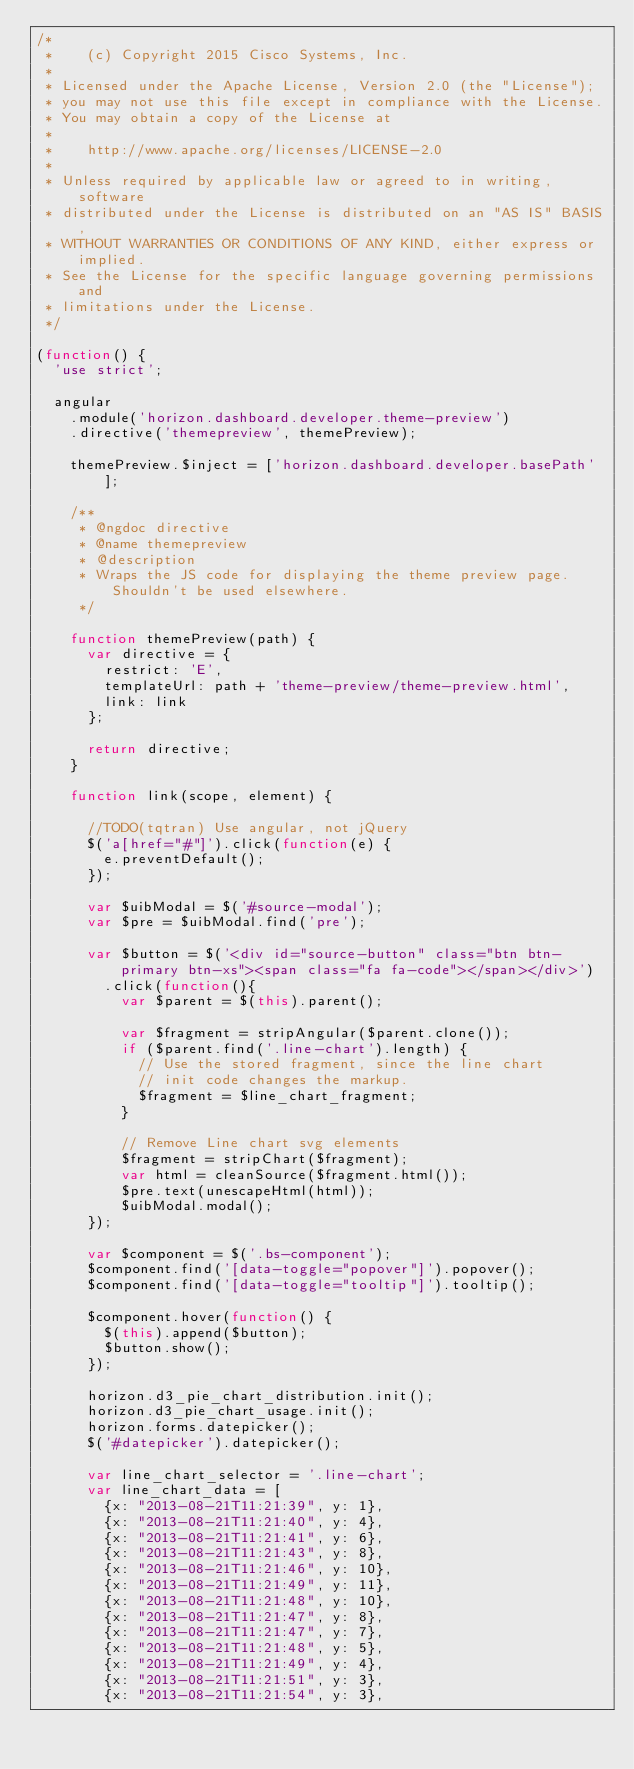<code> <loc_0><loc_0><loc_500><loc_500><_JavaScript_>/*
 *    (c) Copyright 2015 Cisco Systems, Inc.
 *
 * Licensed under the Apache License, Version 2.0 (the "License");
 * you may not use this file except in compliance with the License.
 * You may obtain a copy of the License at
 *
 *    http://www.apache.org/licenses/LICENSE-2.0
 *
 * Unless required by applicable law or agreed to in writing, software
 * distributed under the License is distributed on an "AS IS" BASIS,
 * WITHOUT WARRANTIES OR CONDITIONS OF ANY KIND, either express or implied.
 * See the License for the specific language governing permissions and
 * limitations under the License.
 */

(function() {
  'use strict';

  angular
    .module('horizon.dashboard.developer.theme-preview')
    .directive('themepreview', themePreview);

    themePreview.$inject = ['horizon.dashboard.developer.basePath'];

    /**
     * @ngdoc directive
     * @name themepreview
     * @description
     * Wraps the JS code for displaying the theme preview page. Shouldn't be used elsewhere.
     */

    function themePreview(path) {
      var directive = {
        restrict: 'E',
        templateUrl: path + 'theme-preview/theme-preview.html',
        link: link
      };

      return directive;
    }

    function link(scope, element) {

      //TODO(tqtran) Use angular, not jQuery
      $('a[href="#"]').click(function(e) {
        e.preventDefault();
      });

      var $uibModal = $('#source-modal');
      var $pre = $uibModal.find('pre');

      var $button = $('<div id="source-button" class="btn btn-primary btn-xs"><span class="fa fa-code"></span></div>')
        .click(function(){
          var $parent = $(this).parent();

          var $fragment = stripAngular($parent.clone());
          if ($parent.find('.line-chart').length) {
            // Use the stored fragment, since the line chart
            // init code changes the markup.
            $fragment = $line_chart_fragment;
          }

          // Remove Line chart svg elements
          $fragment = stripChart($fragment);
          var html = cleanSource($fragment.html());
          $pre.text(unescapeHtml(html));
          $uibModal.modal();
      });

      var $component = $('.bs-component');
      $component.find('[data-toggle="popover"]').popover();
      $component.find('[data-toggle="tooltip"]').tooltip();

      $component.hover(function() {
        $(this).append($button);
        $button.show();
      });

      horizon.d3_pie_chart_distribution.init();
      horizon.d3_pie_chart_usage.init();
      horizon.forms.datepicker();
      $('#datepicker').datepicker();

      var line_chart_selector = '.line-chart';
      var line_chart_data = [
        {x: "2013-08-21T11:21:39", y: 1},
        {x: "2013-08-21T11:21:40", y: 4},
        {x: "2013-08-21T11:21:41", y: 6},
        {x: "2013-08-21T11:21:43", y: 8},
        {x: "2013-08-21T11:21:46", y: 10},
        {x: "2013-08-21T11:21:49", y: 11},
        {x: "2013-08-21T11:21:48", y: 10},
        {x: "2013-08-21T11:21:47", y: 8},
        {x: "2013-08-21T11:21:47", y: 7},
        {x: "2013-08-21T11:21:48", y: 5},
        {x: "2013-08-21T11:21:49", y: 4},
        {x: "2013-08-21T11:21:51", y: 3},
        {x: "2013-08-21T11:21:54", y: 3},</code> 